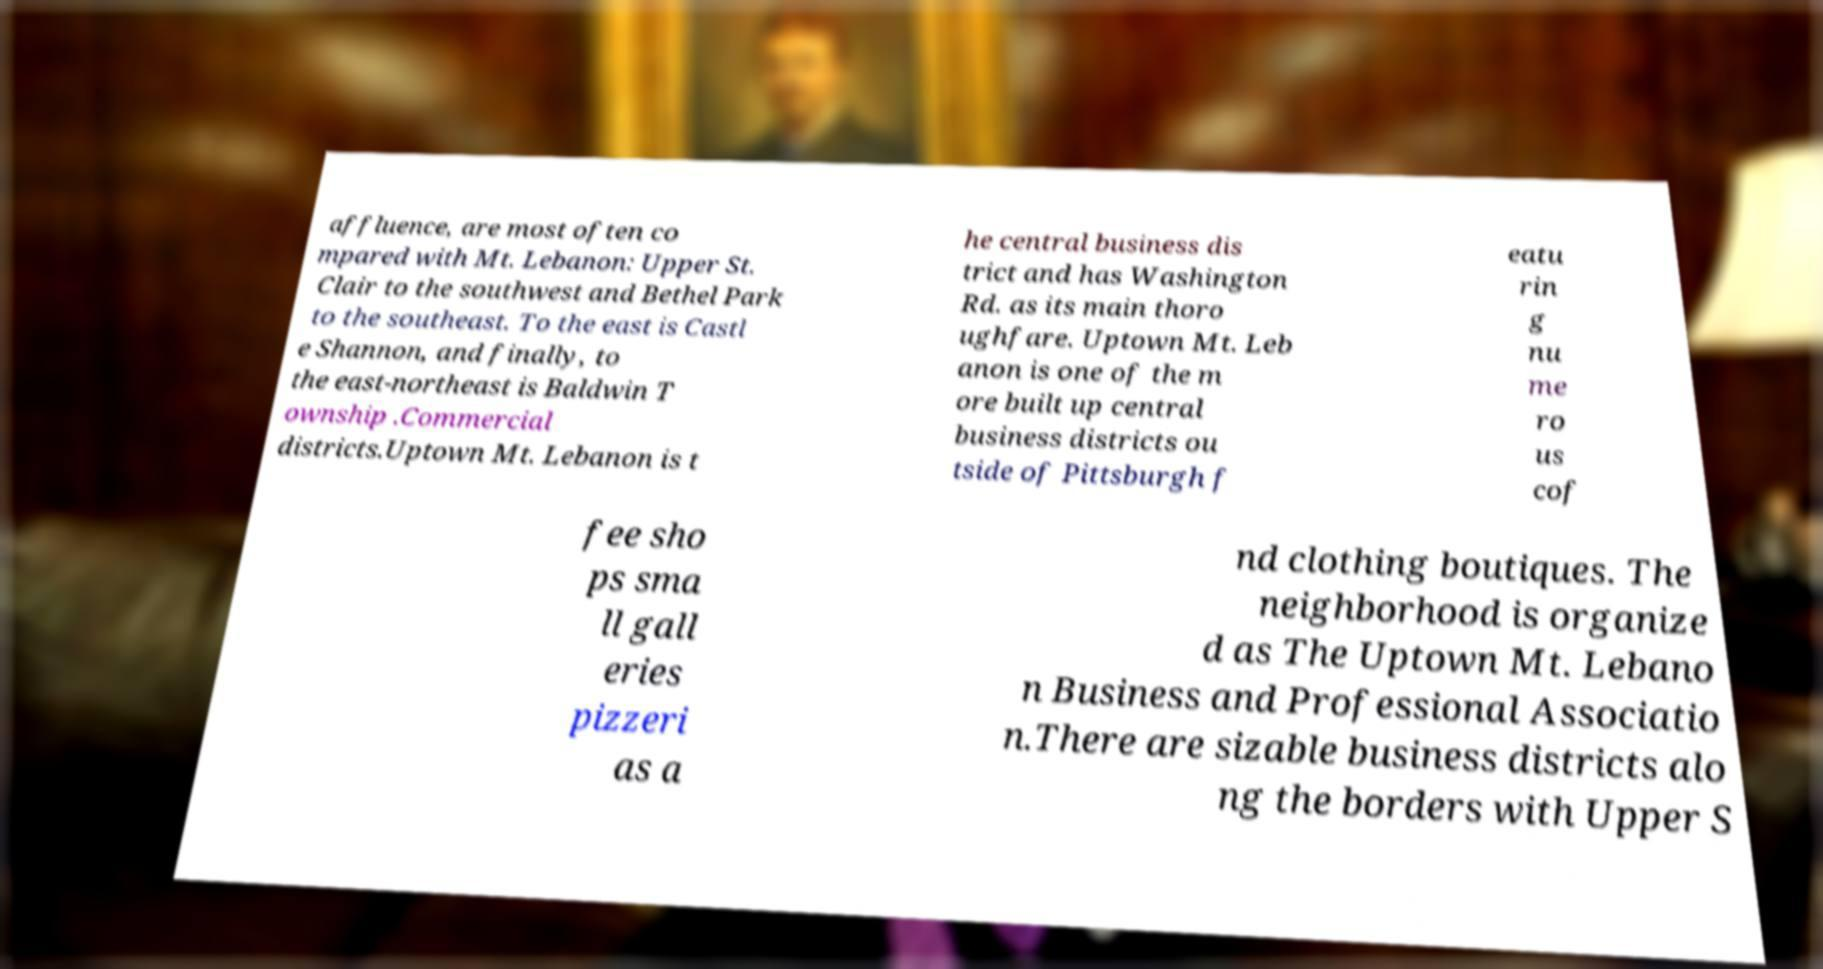Can you read and provide the text displayed in the image?This photo seems to have some interesting text. Can you extract and type it out for me? affluence, are most often co mpared with Mt. Lebanon: Upper St. Clair to the southwest and Bethel Park to the southeast. To the east is Castl e Shannon, and finally, to the east-northeast is Baldwin T ownship .Commercial districts.Uptown Mt. Lebanon is t he central business dis trict and has Washington Rd. as its main thoro ughfare. Uptown Mt. Leb anon is one of the m ore built up central business districts ou tside of Pittsburgh f eatu rin g nu me ro us cof fee sho ps sma ll gall eries pizzeri as a nd clothing boutiques. The neighborhood is organize d as The Uptown Mt. Lebano n Business and Professional Associatio n.There are sizable business districts alo ng the borders with Upper S 